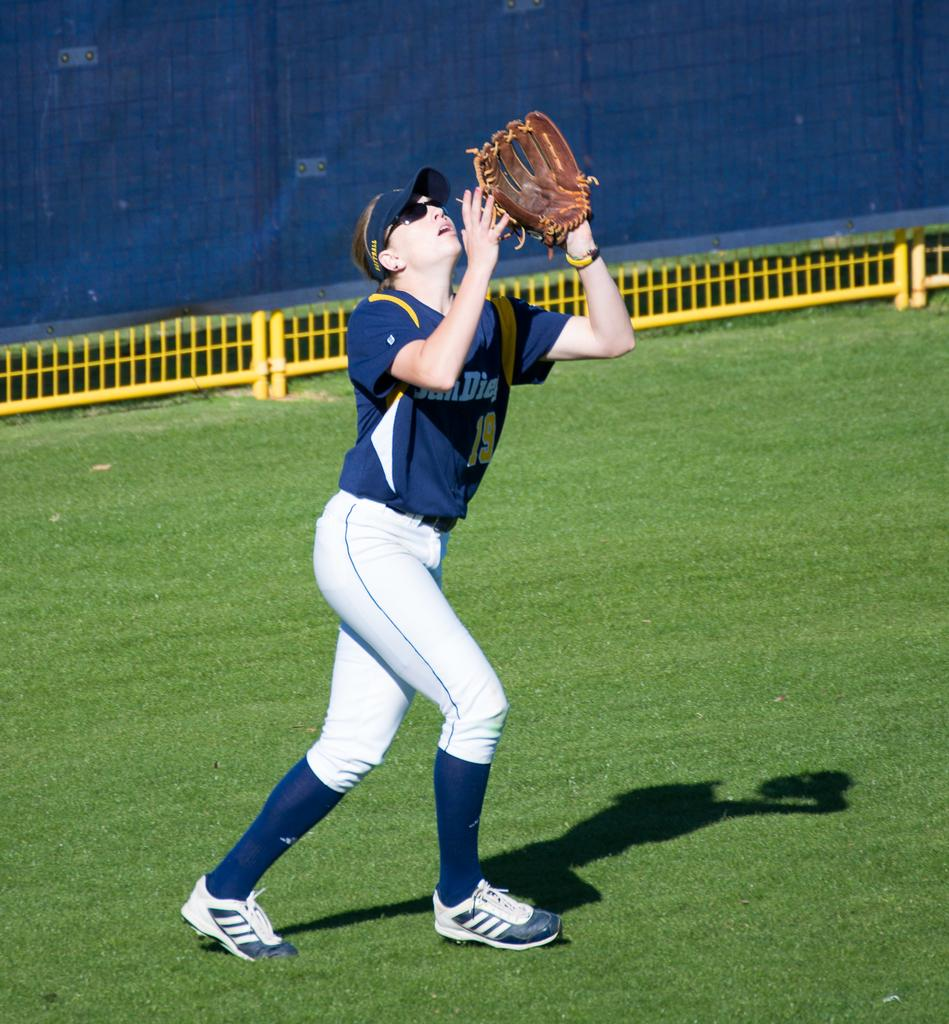<image>
Relay a brief, clear account of the picture shown. Female baseball player number nineteen that is playing for San Diego. 